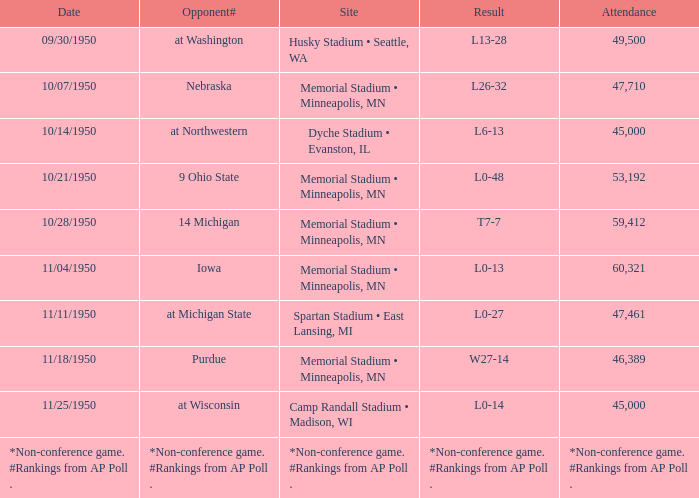How many people are present when the result stands at 10-13? 60321.0. 